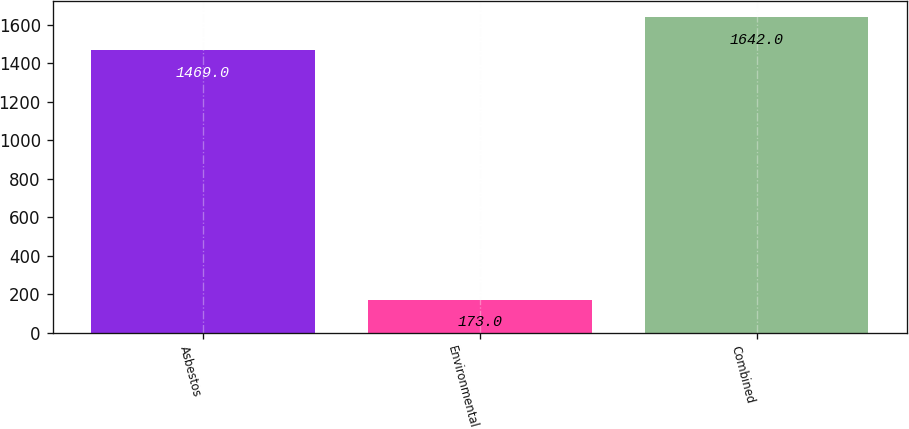<chart> <loc_0><loc_0><loc_500><loc_500><bar_chart><fcel>Asbestos<fcel>Environmental<fcel>Combined<nl><fcel>1469<fcel>173<fcel>1642<nl></chart> 